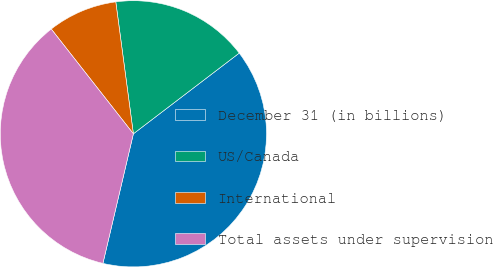<chart> <loc_0><loc_0><loc_500><loc_500><pie_chart><fcel>December 31 (in billions)<fcel>US/Canada<fcel>International<fcel>Total assets under supervision<nl><fcel>39.04%<fcel>16.74%<fcel>8.47%<fcel>35.74%<nl></chart> 